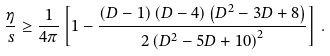Convert formula to latex. <formula><loc_0><loc_0><loc_500><loc_500>\frac { \eta } { s } \geq \frac { 1 } { 4 \pi } \left [ 1 - \frac { \left ( D - 1 \right ) \left ( D - 4 \right ) \left ( D ^ { 2 } - 3 D + 8 \right ) } { 2 \left ( D ^ { 2 } - 5 D + 1 0 \right ) ^ { 2 } } \right ] \, . \label l { l b o u n d }</formula> 